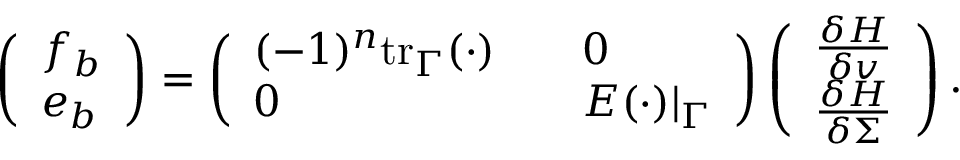Convert formula to latex. <formula><loc_0><loc_0><loc_500><loc_500>\begin{array} { r } { \left ( \begin{array} { l } { f _ { b } } \\ { e _ { b } } \end{array} \right ) = \left ( \begin{array} { l l } { ( - 1 ) ^ { n } t r _ { \Gamma } ( \cdot ) \quad } & { 0 } \\ { 0 \quad } & { E ( \cdot ) | _ { \Gamma } } \end{array} \right ) \left ( \begin{array} { l } { \frac { \delta H } { \delta v } } \\ { \frac { \delta H } { \delta \Sigma } } \end{array} \right ) . } \end{array}</formula> 